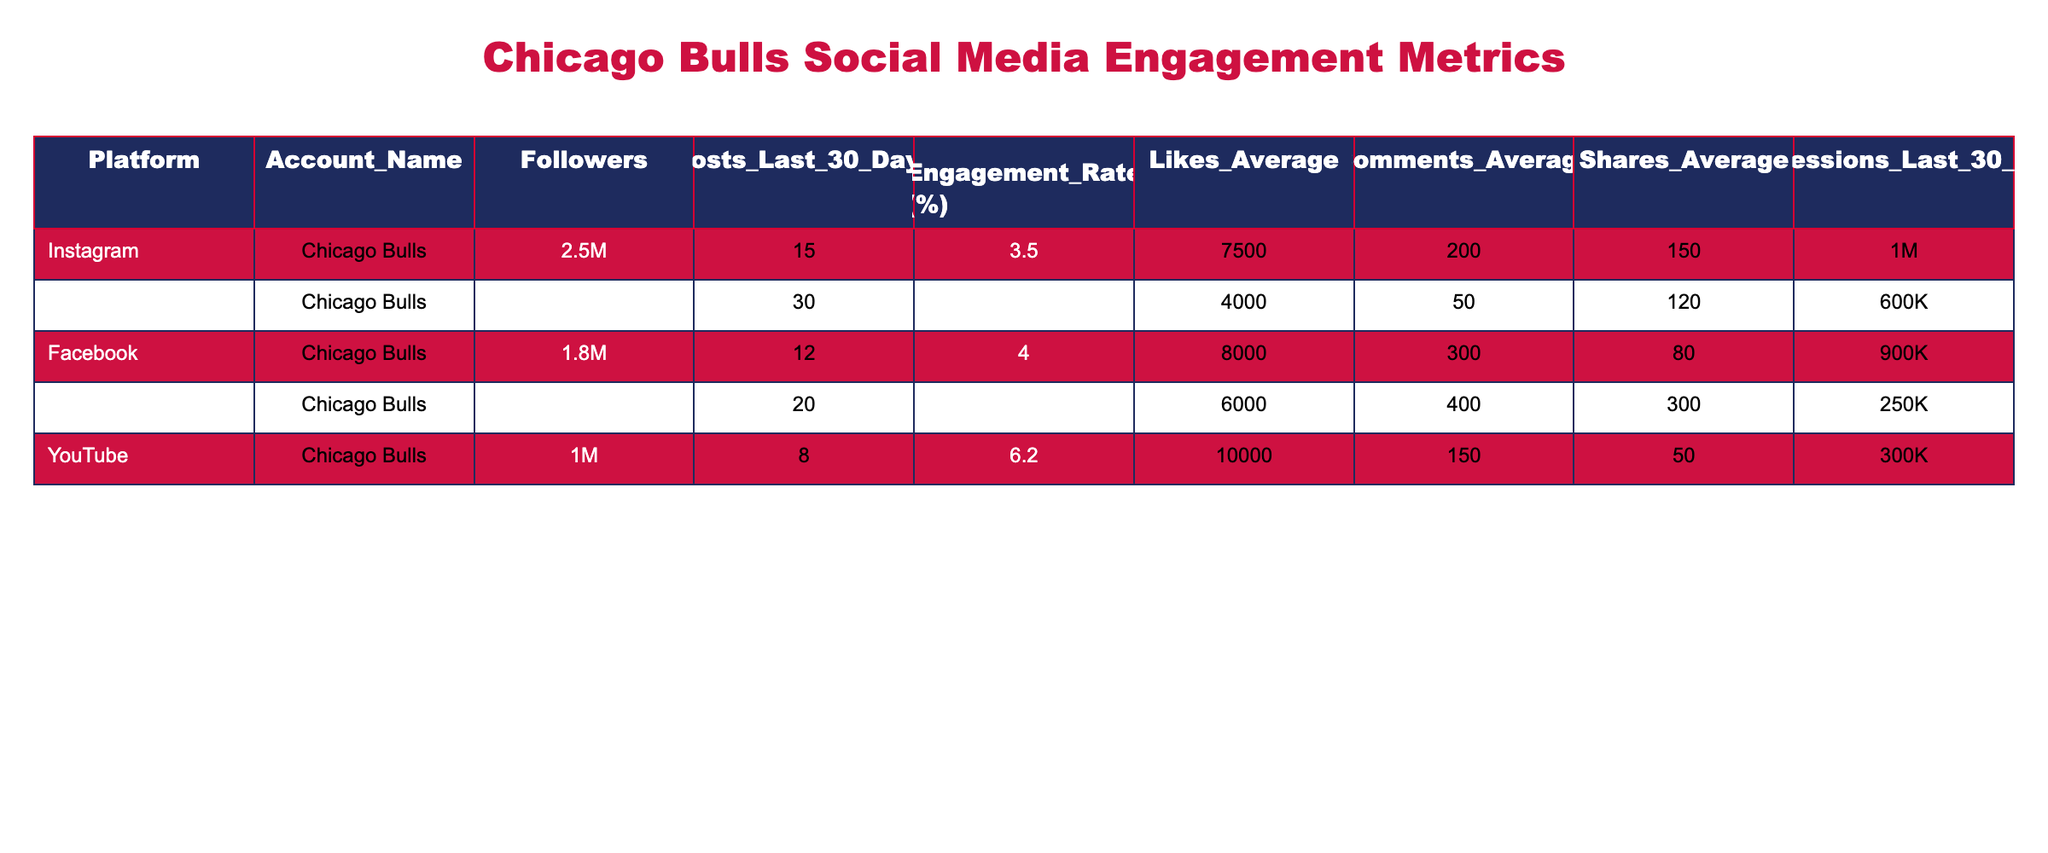What is the engagement rate for the TikTok account? The engagement rate for the TikTok account is directly listed in the table under the "Engagement Rate (%)" column for the TikTok row. It shows 12.5%.
Answer: 12.5% How many followers does the Chicago Bulls have on Instagram? The number of followers for the Chicago Bulls on Instagram is in the "Followers" column under the Instagram row, which indicates 2.5 million.
Answer: 2.5M Which platform has the highest average likes per post? To find the platform with the highest average likes, I will look at the "Likes Average" column. The TikTok account has 6000 likes on average, while the YouTube account has 10000 — which is higher than all the others. Therefore, YouTube has the highest average likes per post.
Answer: YouTube What is the total number of posts made across all platforms in the last 30 days? I need to add the values from the "Posts Last 30 Days" column for each platform. The total is calculated as follows: 15 (Instagram) + 30 (Twitter) + 12 (Facebook) + 20 (TikTok) + 8 (YouTube) = 85 posts.
Answer: 85 Does the Chicago Bulls have more Facebook followers than Twitter followers? By comparing the "Followers" column for Facebook (1.8M) and Twitter (1.2M), Facebook has more followers since 1.8 million is greater than 1.2 million.
Answer: Yes What is the average engagement rate across all platforms? To find the average engagement rate, I will add all the engagement rates from the "Engagement Rate (%)" column and divide by the number of platforms (5). The calculation is (3.5 + 2.8 + 4.0 + 12.5 + 6.2) / 5 = 5.4%.
Answer: 5.4% Which platform has the lowest number of shares on average? Analyzing the "Shares Average" column, I can assess the average shares for each platform and see that Twitter has 120 shares, which is the least compared to the other platforms.
Answer: Twitter How many total impressions did the Chicago Bulls get across all platforms in the last 30 days? To find the total impressions, I will sum the values in the "Impressions Last 30 Days" column: 1M (Instagram) + 600K (Twitter) + 900K (Facebook) + 250K (TikTok) + 300K (YouTube) = 3.05M impressions.
Answer: 3.05M Does the TikTok account have a higher engagement rate than the YouTube account? Comparing the engagement rates, TikTok has 12.5% while YouTube has 6.2%. Since 12.5% is greater than 6.2%, then yes, TikTok has a higher engagement rate.
Answer: Yes 